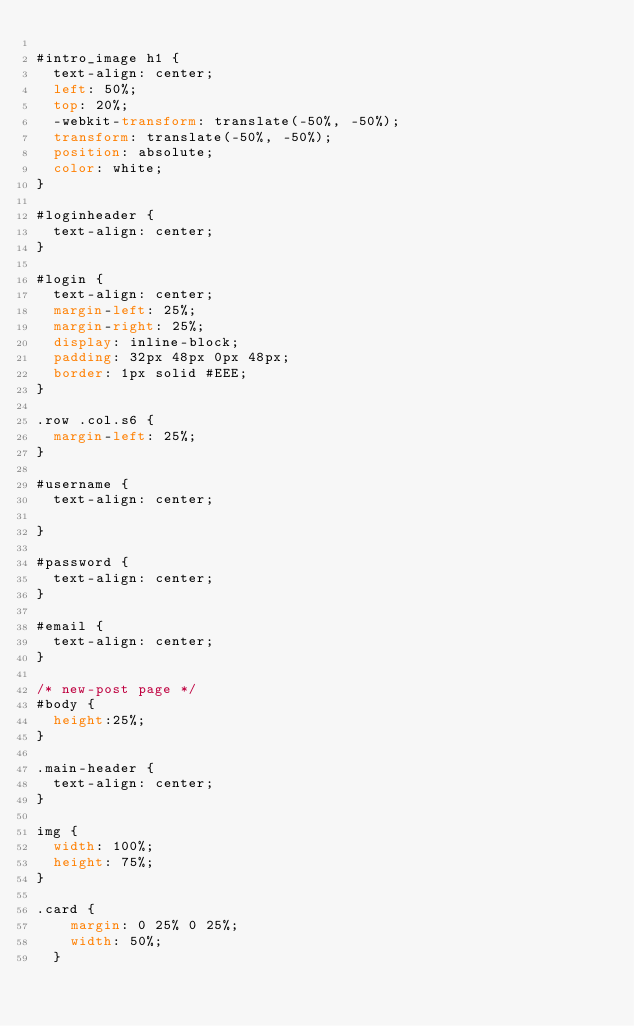Convert code to text. <code><loc_0><loc_0><loc_500><loc_500><_CSS_>
#intro_image h1 {
  text-align: center;
  left: 50%;
  top: 20%;
  -webkit-transform: translate(-50%, -50%);
  transform: translate(-50%, -50%);
  position: absolute;
  color: white;
}

#loginheader {
  text-align: center;
}

#login {
  text-align: center;
  margin-left: 25%;
  margin-right: 25%;
  display: inline-block;
  padding: 32px 48px 0px 48px;
  border: 1px solid #EEE;
}

.row .col.s6 {
  margin-left: 25%;
}

#username {
  text-align: center;

}

#password {
  text-align: center;
}

#email {
  text-align: center;
}

/* new-post page */
#body {
  height:25%;
}

.main-header {
  text-align: center;
}

img {
  width: 100%;
  height: 75%;
}

.card {
    margin: 0 25% 0 25%;
    width: 50%;
  }
</code> 